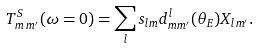Convert formula to latex. <formula><loc_0><loc_0><loc_500><loc_500>T ^ { S } _ { m \, m ^ { \prime } } ( \omega = 0 ) = \sum _ { l } s _ { l m } d ^ { l } _ { m m ^ { \prime } } ( \theta _ { E } ) X _ { l m ^ { \prime } } .</formula> 